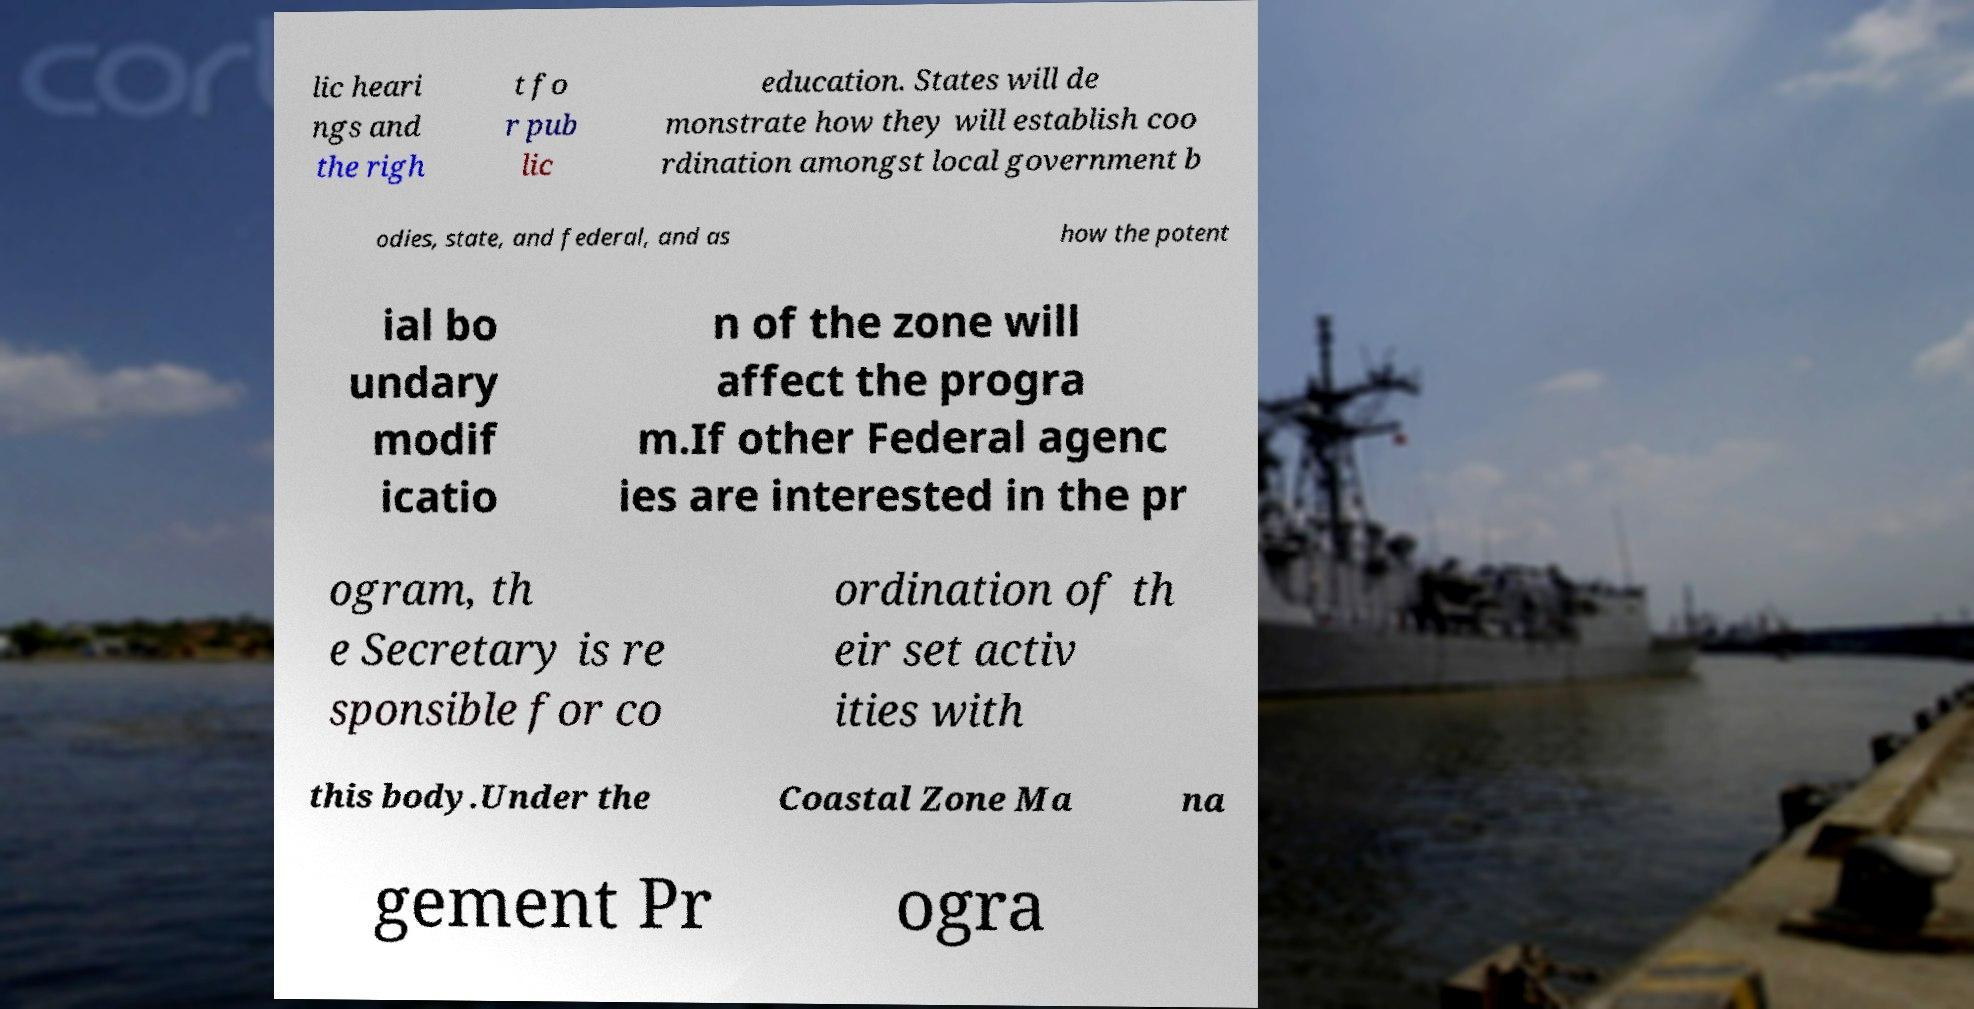What messages or text are displayed in this image? I need them in a readable, typed format. lic heari ngs and the righ t fo r pub lic education. States will de monstrate how they will establish coo rdination amongst local government b odies, state, and federal, and as how the potent ial bo undary modif icatio n of the zone will affect the progra m.If other Federal agenc ies are interested in the pr ogram, th e Secretary is re sponsible for co ordination of th eir set activ ities with this body.Under the Coastal Zone Ma na gement Pr ogra 